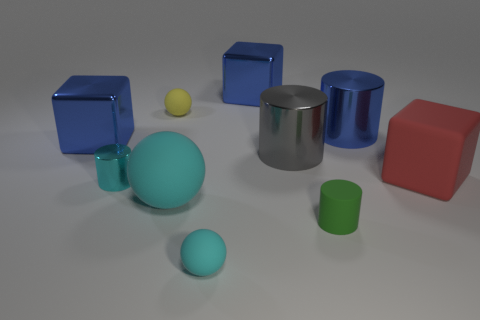The matte cylinder in front of the shiny cube behind the tiny matte thing behind the big blue shiny cylinder is what color? The matte cylinder positioned in the foreground in front of the shiny cube appears to be a turquoise or light blue color. It has a muted finish, which contrasts with the reflective surface of the neighboring shiny cube. 